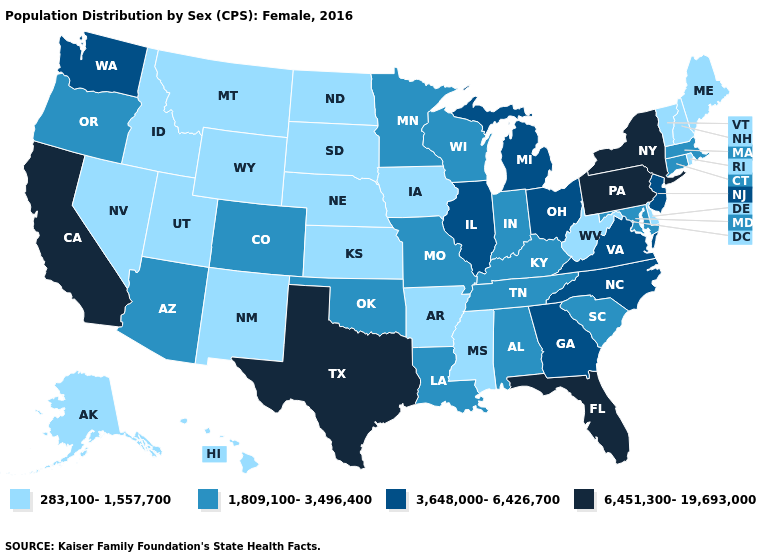Does North Dakota have the lowest value in the MidWest?
Concise answer only. Yes. Does Texas have the highest value in the South?
Be succinct. Yes. Does Kentucky have the highest value in the South?
Give a very brief answer. No. Does Delaware have the lowest value in the South?
Give a very brief answer. Yes. Does the first symbol in the legend represent the smallest category?
Keep it brief. Yes. Which states have the lowest value in the Northeast?
Concise answer only. Maine, New Hampshire, Rhode Island, Vermont. What is the highest value in the Northeast ?
Write a very short answer. 6,451,300-19,693,000. What is the highest value in the USA?
Write a very short answer. 6,451,300-19,693,000. Does California have the highest value in the West?
Be succinct. Yes. Does the first symbol in the legend represent the smallest category?
Keep it brief. Yes. What is the lowest value in the USA?
Answer briefly. 283,100-1,557,700. What is the value of Oklahoma?
Short answer required. 1,809,100-3,496,400. Name the states that have a value in the range 3,648,000-6,426,700?
Answer briefly. Georgia, Illinois, Michigan, New Jersey, North Carolina, Ohio, Virginia, Washington. How many symbols are there in the legend?
Keep it brief. 4. Which states have the lowest value in the MidWest?
Give a very brief answer. Iowa, Kansas, Nebraska, North Dakota, South Dakota. 